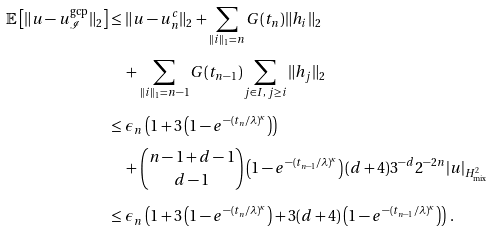Convert formula to latex. <formula><loc_0><loc_0><loc_500><loc_500>\mathbb { E } \left [ \| u - u ^ { \text {gcp} } _ { \mathcal { I } } \| _ { 2 } \right ] & \leq \| u - u ^ { c } _ { n } \| _ { 2 } + \sum _ { \| i \| _ { 1 } = n } G ( t _ { n } ) \| h _ { i } \| _ { 2 } \\ & \quad + \sum _ { \| i \| _ { 1 } = n - 1 } G ( t _ { n - 1 } ) \sum _ { j \in I , \, j \geq i } \| h _ { j } \| _ { 2 } \\ & \leq \epsilon _ { n } \left ( 1 + 3 \left ( 1 - e ^ { - ( t _ { n } / \lambda ) ^ { \kappa } } \right ) \right ) \\ & \quad + \binom { n - 1 + d - 1 } { d - 1 } \left ( 1 - e ^ { - ( t _ { n - 1 } / \lambda ) ^ { \kappa } } \right ) ( d + 4 ) 3 ^ { - d } 2 ^ { - 2 n } | u | _ { H ^ { 2 } _ { \text {mix} } } \\ & \leq \epsilon _ { n } \left ( 1 + 3 \left ( 1 - e ^ { - ( t _ { n } / \lambda ) ^ { \kappa } } \right ) + 3 ( d + 4 ) \left ( 1 - e ^ { - ( t _ { n - 1 } / \lambda ) ^ { \kappa } } \right ) \right ) \, .</formula> 